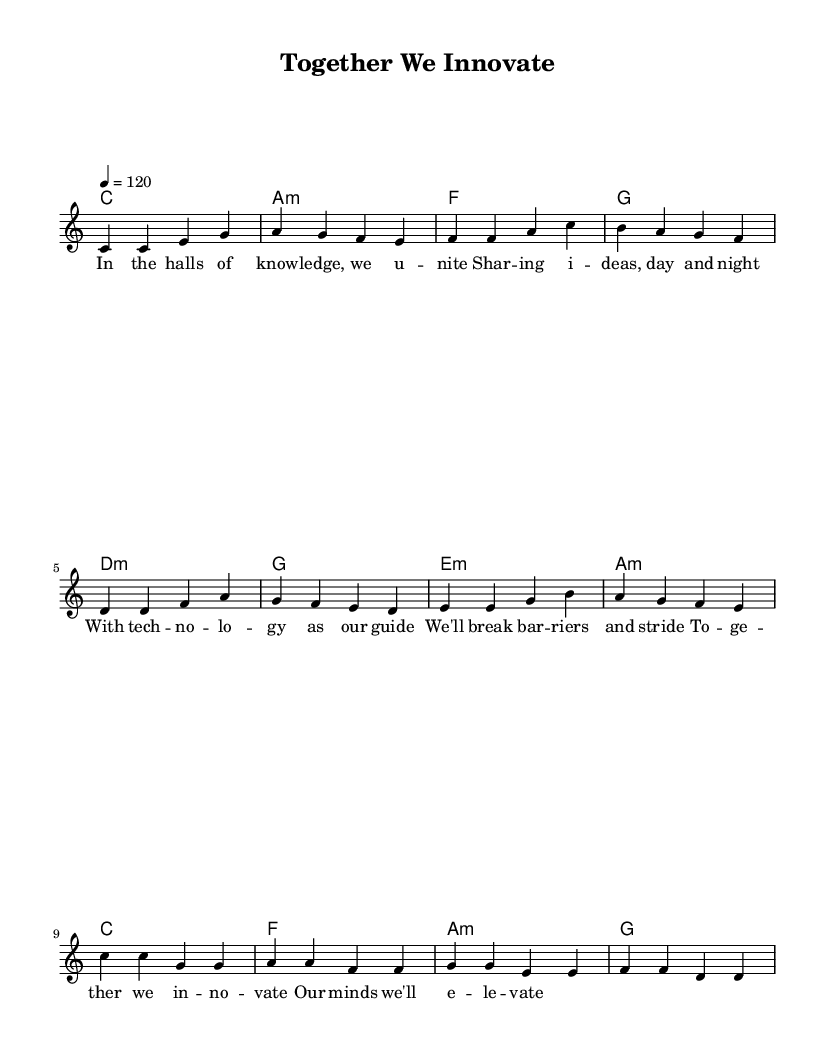What is the key signature of this music? The key signature is C major which is indicated at the beginning of the score with no sharps or flats present.
Answer: C major What is the time signature of this music? The time signature at the beginning of the score is indicated as 4/4, which means there are four beats in each measure.
Answer: 4/4 What is the tempo marking of this piece? The tempo marking of the piece is set to 120 beats per minute, which provides a lively pace for the performance.
Answer: 120 How many measures are in the verse section? By counting the measures indicated in the melody section for the verse, there are four measures present in total.
Answer: 4 What is the chord progression for the pre-chorus? The pre-chorus has the chord progression of D minor, G major, E minor, and A minor, which supports the melody in that section.
Answer: D minor, G major, E minor, A minor Identify a theme expressed in the lyrics. The lyrics focus on collaboration and innovation, emphasizing unity in sharing ideas and breaking barriers together.
Answer: Collaboration and innovation 